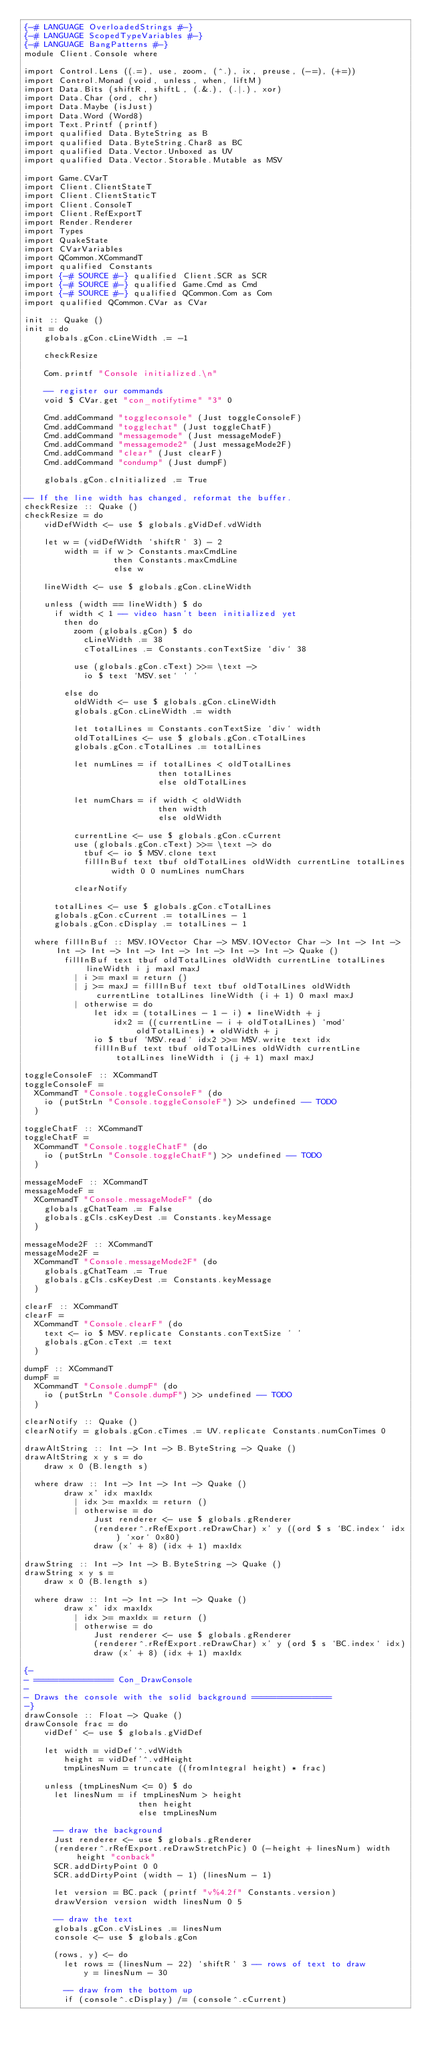Convert code to text. <code><loc_0><loc_0><loc_500><loc_500><_Haskell_>{-# LANGUAGE OverloadedStrings #-}
{-# LANGUAGE ScopedTypeVariables #-}
{-# LANGUAGE BangPatterns #-}
module Client.Console where

import Control.Lens ((.=), use, zoom, (^.), ix, preuse, (-=), (+=))
import Control.Monad (void, unless, when, liftM)
import Data.Bits (shiftR, shiftL, (.&.), (.|.), xor)
import Data.Char (ord, chr)
import Data.Maybe (isJust)
import Data.Word (Word8)
import Text.Printf (printf)
import qualified Data.ByteString as B
import qualified Data.ByteString.Char8 as BC
import qualified Data.Vector.Unboxed as UV
import qualified Data.Vector.Storable.Mutable as MSV

import Game.CVarT
import Client.ClientStateT
import Client.ClientStaticT
import Client.ConsoleT
import Client.RefExportT
import Render.Renderer
import Types
import QuakeState
import CVarVariables
import QCommon.XCommandT
import qualified Constants
import {-# SOURCE #-} qualified Client.SCR as SCR
import {-# SOURCE #-} qualified Game.Cmd as Cmd
import {-# SOURCE #-} qualified QCommon.Com as Com
import qualified QCommon.CVar as CVar

init :: Quake ()
init = do
    globals.gCon.cLineWidth .= -1

    checkResize

    Com.printf "Console initialized.\n"

    -- register our commands
    void $ CVar.get "con_notifytime" "3" 0

    Cmd.addCommand "toggleconsole" (Just toggleConsoleF)
    Cmd.addCommand "togglechat" (Just toggleChatF)
    Cmd.addCommand "messagemode" (Just messageModeF)
    Cmd.addCommand "messagemode2" (Just messageMode2F)
    Cmd.addCommand "clear" (Just clearF)
    Cmd.addCommand "condump" (Just dumpF)

    globals.gCon.cInitialized .= True

-- If the line width has changed, reformat the buffer.
checkResize :: Quake ()
checkResize = do
    vidDefWidth <- use $ globals.gVidDef.vdWidth

    let w = (vidDefWidth `shiftR` 3) - 2
        width = if w > Constants.maxCmdLine
                  then Constants.maxCmdLine
                  else w

    lineWidth <- use $ globals.gCon.cLineWidth

    unless (width == lineWidth) $ do
      if width < 1 -- video hasn't been initialized yet
        then do
          zoom (globals.gCon) $ do
            cLineWidth .= 38
            cTotalLines .= Constants.conTextSize `div` 38

          use (globals.gCon.cText) >>= \text ->
            io $ text `MSV.set` ' '

        else do
          oldWidth <- use $ globals.gCon.cLineWidth
          globals.gCon.cLineWidth .= width

          let totalLines = Constants.conTextSize `div` width
          oldTotalLines <- use $ globals.gCon.cTotalLines
          globals.gCon.cTotalLines .= totalLines

          let numLines = if totalLines < oldTotalLines
                           then totalLines
                           else oldTotalLines

          let numChars = if width < oldWidth
                           then width
                           else oldWidth

          currentLine <- use $ globals.gCon.cCurrent
          use (globals.gCon.cText) >>= \text -> do
            tbuf <- io $ MSV.clone text
            fillInBuf text tbuf oldTotalLines oldWidth currentLine totalLines width 0 0 numLines numChars

          clearNotify

      totalLines <- use $ globals.gCon.cTotalLines
      globals.gCon.cCurrent .= totalLines - 1
      globals.gCon.cDisplay .= totalLines - 1

  where fillInBuf :: MSV.IOVector Char -> MSV.IOVector Char -> Int -> Int -> Int -> Int -> Int -> Int -> Int -> Int -> Int -> Quake ()
        fillInBuf text tbuf oldTotalLines oldWidth currentLine totalLines lineWidth i j maxI maxJ
          | i >= maxI = return ()
          | j >= maxJ = fillInBuf text tbuf oldTotalLines oldWidth currentLine totalLines lineWidth (i + 1) 0 maxI maxJ
          | otherwise = do
              let idx = (totalLines - 1 - i) * lineWidth + j
                  idx2 = ((currentLine - i + oldTotalLines) `mod` oldTotalLines) * oldWidth + j
              io $ tbuf `MSV.read` idx2 >>= MSV.write text idx
              fillInBuf text tbuf oldTotalLines oldWidth currentLine totalLines lineWidth i (j + 1) maxI maxJ

toggleConsoleF :: XCommandT
toggleConsoleF =
  XCommandT "Console.toggleConsoleF" (do
    io (putStrLn "Console.toggleConsoleF") >> undefined -- TODO
  )

toggleChatF :: XCommandT
toggleChatF =
  XCommandT "Console.toggleChatF" (do
    io (putStrLn "Console.toggleChatF") >> undefined -- TODO
  )

messageModeF :: XCommandT
messageModeF =
  XCommandT "Console.messageModeF" (do
    globals.gChatTeam .= False
    globals.gCls.csKeyDest .= Constants.keyMessage
  )

messageMode2F :: XCommandT
messageMode2F =
  XCommandT "Console.messageMode2F" (do
    globals.gChatTeam .= True
    globals.gCls.csKeyDest .= Constants.keyMessage
  )

clearF :: XCommandT
clearF =
  XCommandT "Console.clearF" (do
    text <- io $ MSV.replicate Constants.conTextSize ' '
    globals.gCon.cText .= text
  )

dumpF :: XCommandT
dumpF =
  XCommandT "Console.dumpF" (do
    io (putStrLn "Console.dumpF") >> undefined -- TODO
  )

clearNotify :: Quake ()
clearNotify = globals.gCon.cTimes .= UV.replicate Constants.numConTimes 0

drawAltString :: Int -> Int -> B.ByteString -> Quake ()
drawAltString x y s = do
    draw x 0 (B.length s)

  where draw :: Int -> Int -> Int -> Quake ()
        draw x' idx maxIdx
          | idx >= maxIdx = return ()
          | otherwise = do
              Just renderer <- use $ globals.gRenderer
              (renderer^.rRefExport.reDrawChar) x' y ((ord $ s `BC.index` idx) `xor` 0x80)
              draw (x' + 8) (idx + 1) maxIdx

drawString :: Int -> Int -> B.ByteString -> Quake ()
drawString x y s =
    draw x 0 (B.length s)

  where draw :: Int -> Int -> Int -> Quake ()
        draw x' idx maxIdx
          | idx >= maxIdx = return ()
          | otherwise = do
              Just renderer <- use $ globals.gRenderer
              (renderer^.rRefExport.reDrawChar) x' y (ord $ s `BC.index` idx)
              draw (x' + 8) (idx + 1) maxIdx

{-
- ================ Con_DrawConsole
- 
- Draws the console with the solid background ================
-}
drawConsole :: Float -> Quake ()
drawConsole frac = do
    vidDef' <- use $ globals.gVidDef

    let width = vidDef'^.vdWidth
        height = vidDef'^.vdHeight
        tmpLinesNum = truncate ((fromIntegral height) * frac)

    unless (tmpLinesNum <= 0) $ do
      let linesNum = if tmpLinesNum > height
                       then height
                       else tmpLinesNum

      -- draw the background
      Just renderer <- use $ globals.gRenderer
      (renderer^.rRefExport.reDrawStretchPic) 0 (-height + linesNum) width height "conback"
      SCR.addDirtyPoint 0 0
      SCR.addDirtyPoint (width - 1) (linesNum - 1)

      let version = BC.pack (printf "v%4.2f" Constants.version)
      drawVersion version width linesNum 0 5

      -- draw the text
      globals.gCon.cVisLines .= linesNum
      console <- use $ globals.gCon

      (rows, y) <- do
        let rows = (linesNum - 22) `shiftR` 3 -- rows of text to draw
            y = linesNum - 30

        -- draw from the bottom up
        if (console^.cDisplay) /= (console^.cCurrent)</code> 